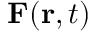Convert formula to latex. <formula><loc_0><loc_0><loc_500><loc_500>F ( r , t )</formula> 